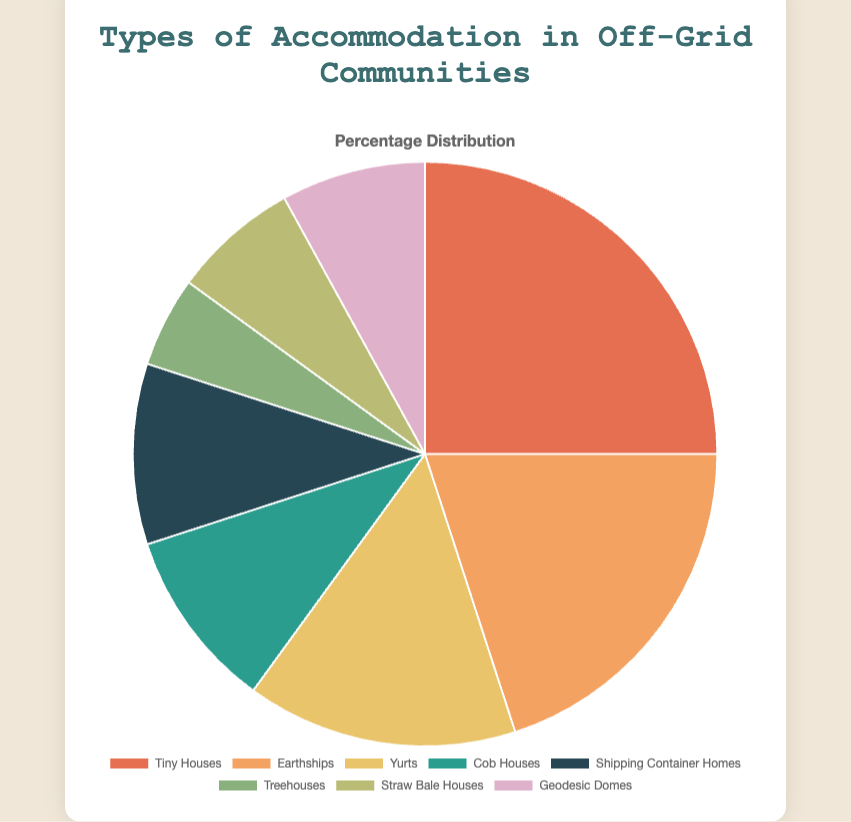Which type of accommodation has the highest percentage? First, identify the slice that visually occupies the largest area of the pie chart. The "Tiny Houses" slice is the largest. Then, refer to the proportion value, which is 25%.
Answer: Tiny Houses Which types of accommodation have the same percentage? Look for slices that seem to occupy the same area and then check their percentages. "Cob Houses" and "Shipping Container Homes" both occupy similar areas and each has a 10% proportion.
Answer: Cob Houses and Shipping Container Homes What is the total percentage of Earthships and Yurts? Identify the Earthships and Yurts slices on the pie chart. Earthships have a 20% proportion and Yurts have 15%. Add these percentages together: 20% + 15% = 35%.
Answer: 35% Which type of accommodation has the smallest percentage? Find the smallest slice on the pie chart, which visually occupies the least area. The "Treehouses" slice is the smallest and has a 5% proportion.
Answer: Treehouses By how much does the percentage of Tiny Houses exceed that of Geodesic Domes? Look at the percentages for Tiny Houses and Geodesic Domes in the chart: Tiny Houses are 25% and Geodesic Domes are 8%. Subtract the percentage of Geodesic Domes from that of Tiny Houses: 25% - 8% = 17%.
Answer: 17% What combined percentage do Cob Houses and Straw Bale Houses constitute? Find the Cob Houses and Straw Bale Houses slices, with percentages of 10% and 7%, respectively. Add these percentages together: 10% + 7% = 17%.
Answer: 17% Which color is used to represent Yurts on the pie chart? Identify the label "Yurts" and its corresponding slice on the pie chart to determine the color used. The color for Yurts is visually noticeable as a shade of yellow.
Answer: Yellow Are there more Earthships or Treehouses in terms of percentage? Compare the sizes of the Earthships and Treehouses slices on the pie chart. Earthships have a larger slice at 20%, whereas Treehouses have a smaller slice at 5%.
Answer: Earthships How much larger is the proportion of Tiny Houses compared to Straw Bale Houses? Locate the percentages for Tiny Houses and Straw Bale Houses on the pie chart: Tiny Houses are 25% and Straw Bale Houses are 7%. Subtract the smaller percentage from the larger: 25% - 7% = 18%.
Answer: 18% What is the average percentage of Yurts, Cob Houses, and Geodesic Domes? Identify the percentages for Yurts, Cob Houses, and Geodesic Domes: Yurts 15%, Cob Houses 10%, Geodesic Domes 8%. Add these percentages together and then divide by 3: (15% + 10% + 8%) / 3 = 33% / 3 = 11%.
Answer: 11% 